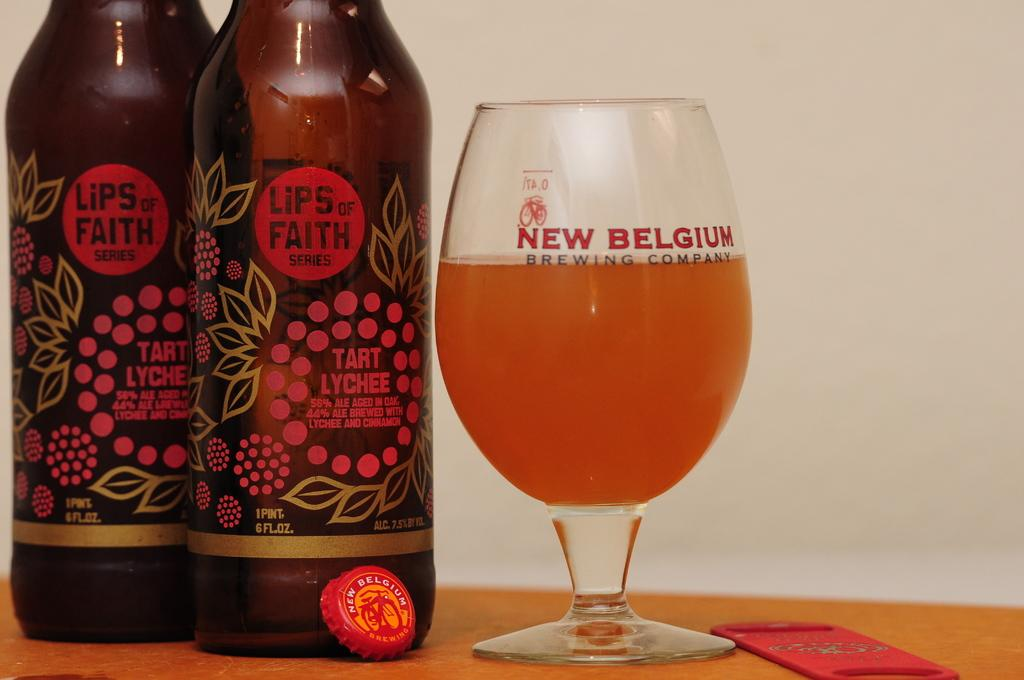How many bottles of drink can be seen in the image? There are two bottles of drink in the image. What else is filled with a drink in the image? There is a glass filled with a drink in the image. Where are the bottles and glass located? The glass and bottles are placed on a table. What can be seen in the background of the image? There is a wall in the background of the image. Can you tell me how many snakes are slithering on the table in the image? There are no snakes present in the image; the table only contains bottles of drink, a glass filled with a drink, and possibly other items not mentioned in the facts. 